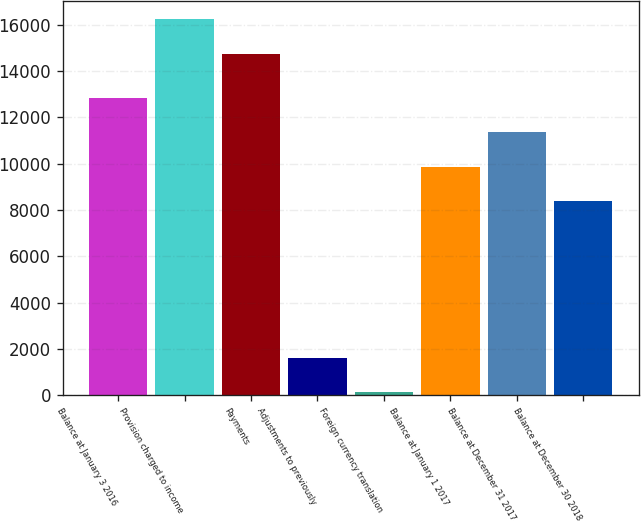<chart> <loc_0><loc_0><loc_500><loc_500><bar_chart><fcel>Balance at January 3 2016<fcel>Provision charged to income<fcel>Payments<fcel>Adjustments to previously<fcel>Foreign currency translation<fcel>Balance at January 1 2017<fcel>Balance at December 31 2017<fcel>Balance at December 30 2018<nl><fcel>12823.4<fcel>16225.8<fcel>14749<fcel>1609.8<fcel>133<fcel>9869.8<fcel>11346.6<fcel>8393<nl></chart> 